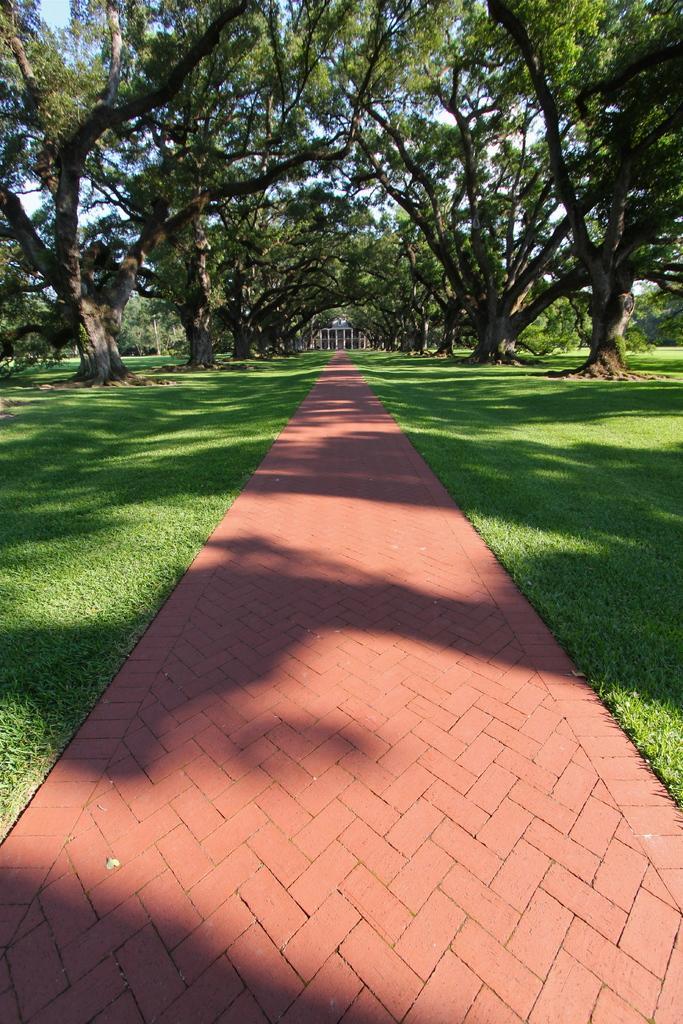Describe this image in one or two sentences. In this image there is a path. Background there are trees on the grassland. There is a building in the middle of the image. 